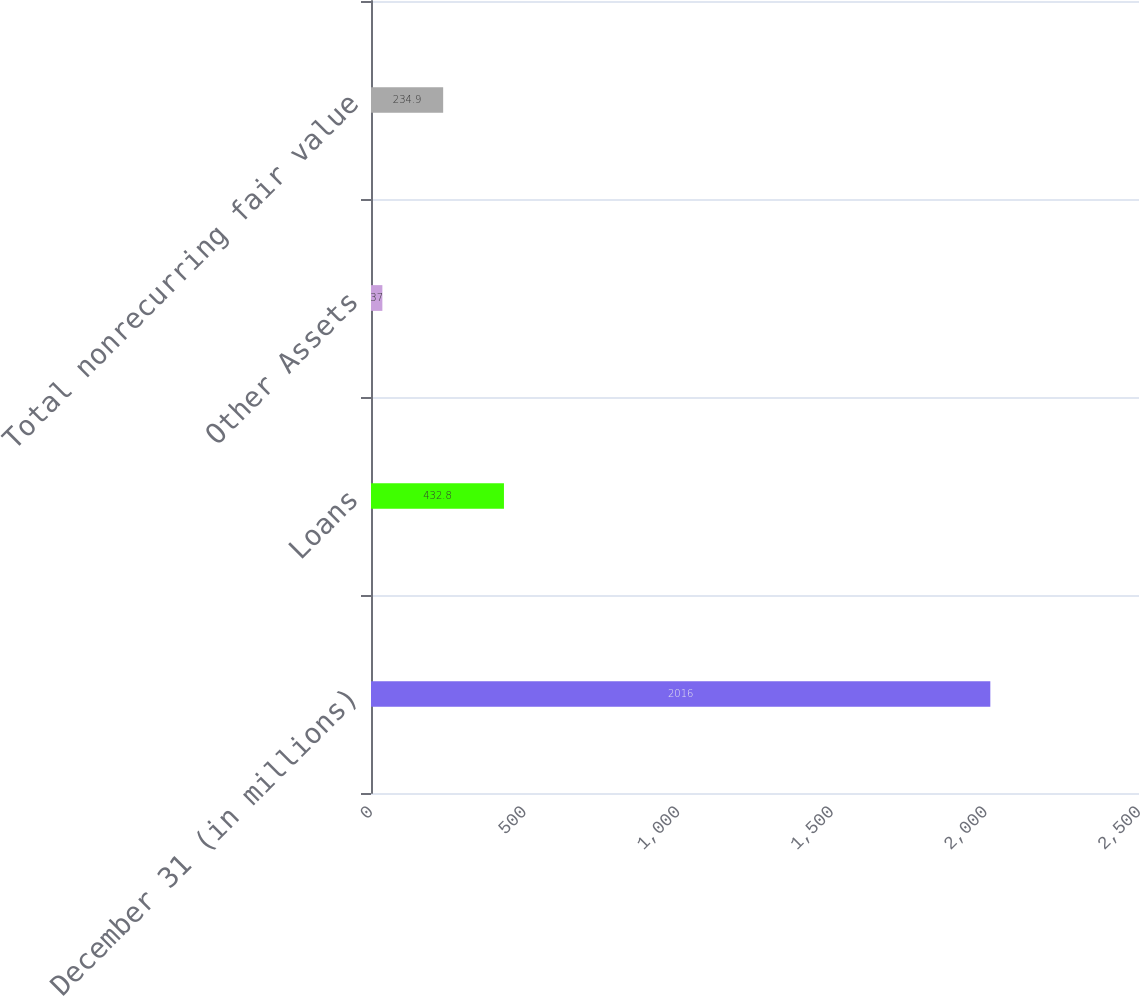Convert chart. <chart><loc_0><loc_0><loc_500><loc_500><bar_chart><fcel>December 31 (in millions)<fcel>Loans<fcel>Other Assets<fcel>Total nonrecurring fair value<nl><fcel>2016<fcel>432.8<fcel>37<fcel>234.9<nl></chart> 